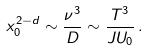<formula> <loc_0><loc_0><loc_500><loc_500>x _ { 0 } ^ { 2 - d } \sim \frac { \nu ^ { 3 } } { D } \sim \frac { T ^ { 3 } } { J U _ { 0 } } \, .</formula> 